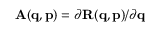Convert formula to latex. <formula><loc_0><loc_0><loc_500><loc_500>A ( q , p ) = \partial R ( q , p ) / \partial q</formula> 